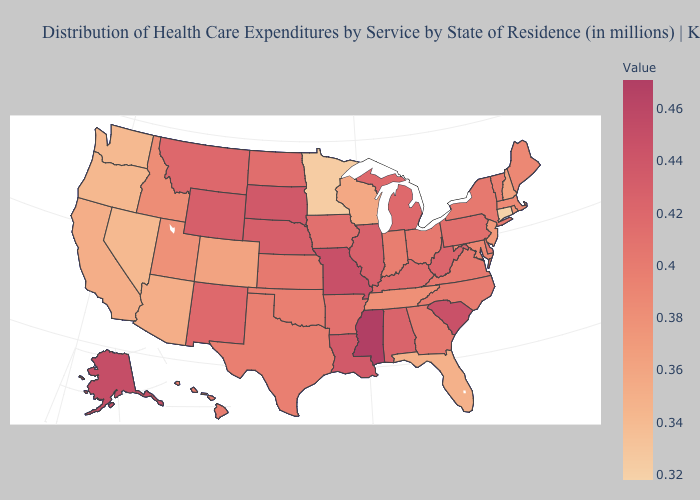Does the map have missing data?
Be succinct. No. Does Florida have the highest value in the South?
Give a very brief answer. No. Does Mississippi have the highest value in the USA?
Quick response, please. Yes. Does Arizona have a higher value than Montana?
Quick response, please. No. Among the states that border Ohio , which have the lowest value?
Concise answer only. Indiana. Among the states that border West Virginia , which have the lowest value?
Be succinct. Maryland. Which states have the lowest value in the USA?
Give a very brief answer. Connecticut. 